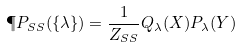Convert formula to latex. <formula><loc_0><loc_0><loc_500><loc_500>\P P _ { S S } ( \{ \lambda \} ) = \frac { 1 } { Z _ { S S } } Q _ { \lambda } ( X ) P _ { \lambda } ( Y )</formula> 